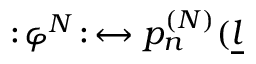Convert formula to latex. <formula><loc_0><loc_0><loc_500><loc_500>\colon \, \varphi ^ { N } \, \colon \, \leftrightarrow p _ { n } ^ { ( N ) } ( \underline { l }</formula> 